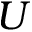<formula> <loc_0><loc_0><loc_500><loc_500>U</formula> 